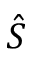Convert formula to latex. <formula><loc_0><loc_0><loc_500><loc_500>\hat { S }</formula> 